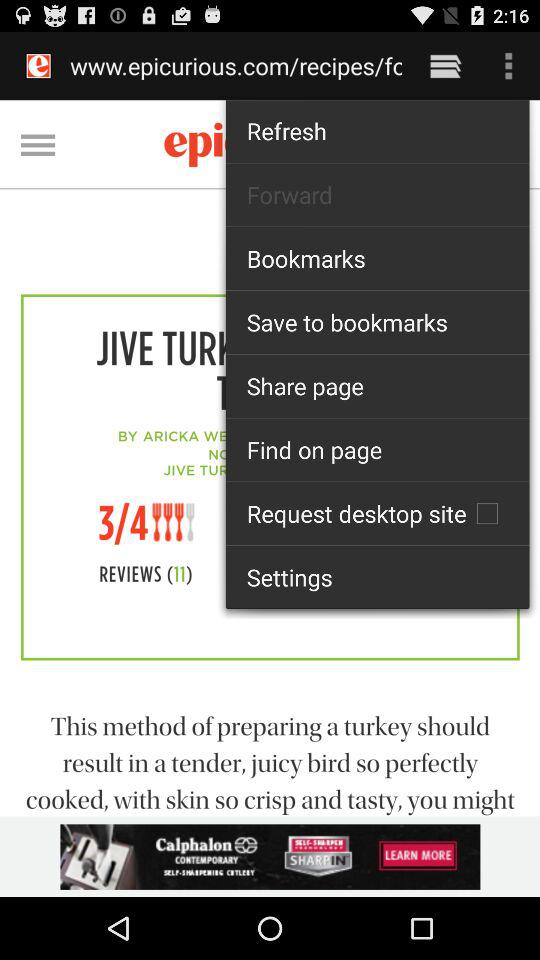What is the status of "Request desktop site"? The status is "off". 